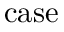<formula> <loc_0><loc_0><loc_500><loc_500>c a s e</formula> 